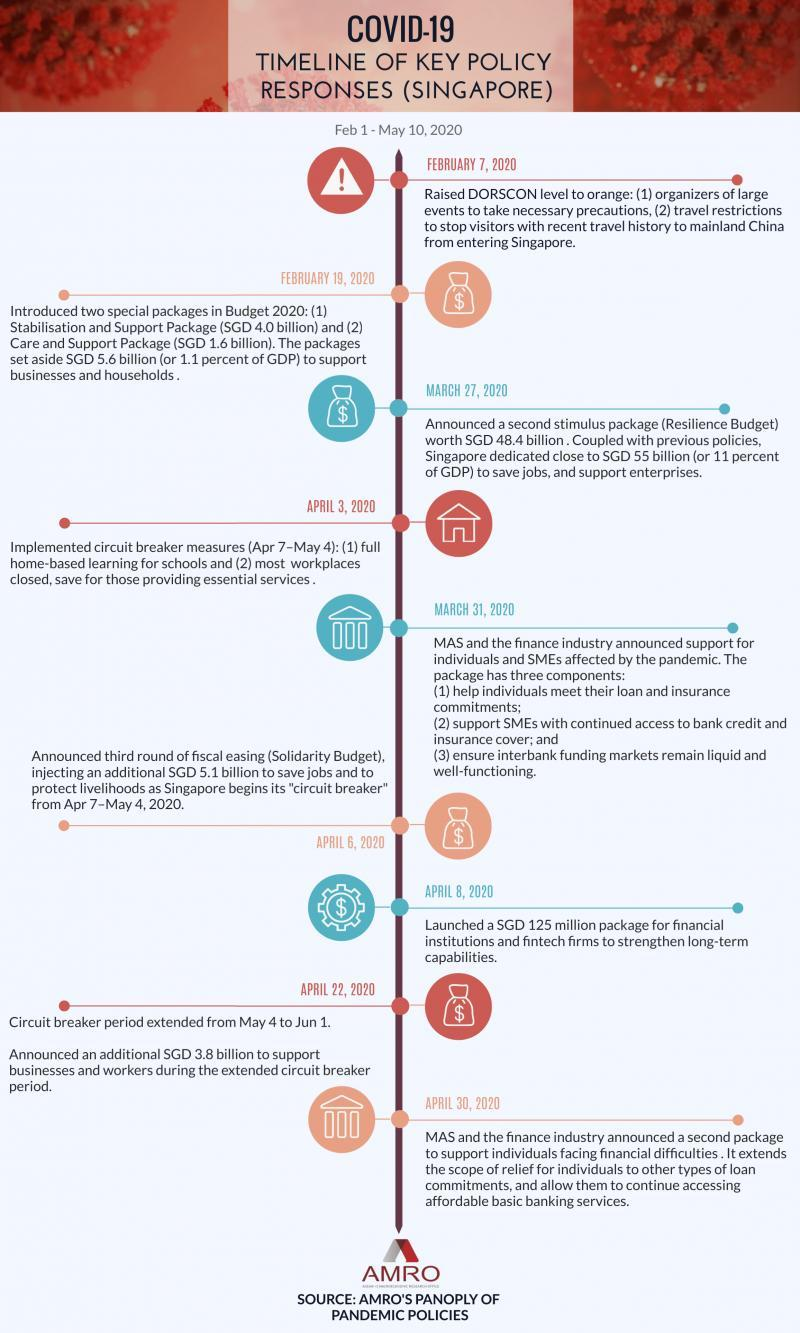How many packages are introduced before April 3?
Answer the question with a short phrase. 3 